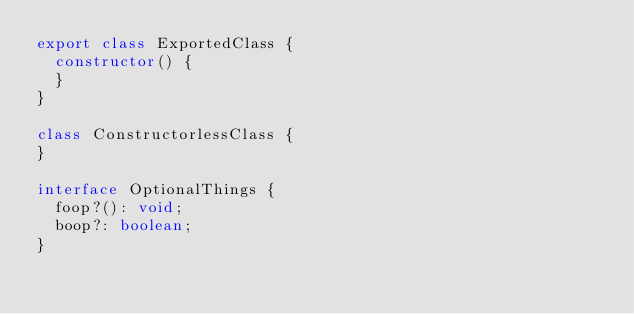<code> <loc_0><loc_0><loc_500><loc_500><_TypeScript_>export class ExportedClass {
  constructor() {
  }
}

class ConstructorlessClass {
}

interface OptionalThings {
  foop?(): void;
  boop?: boolean;
}
</code> 